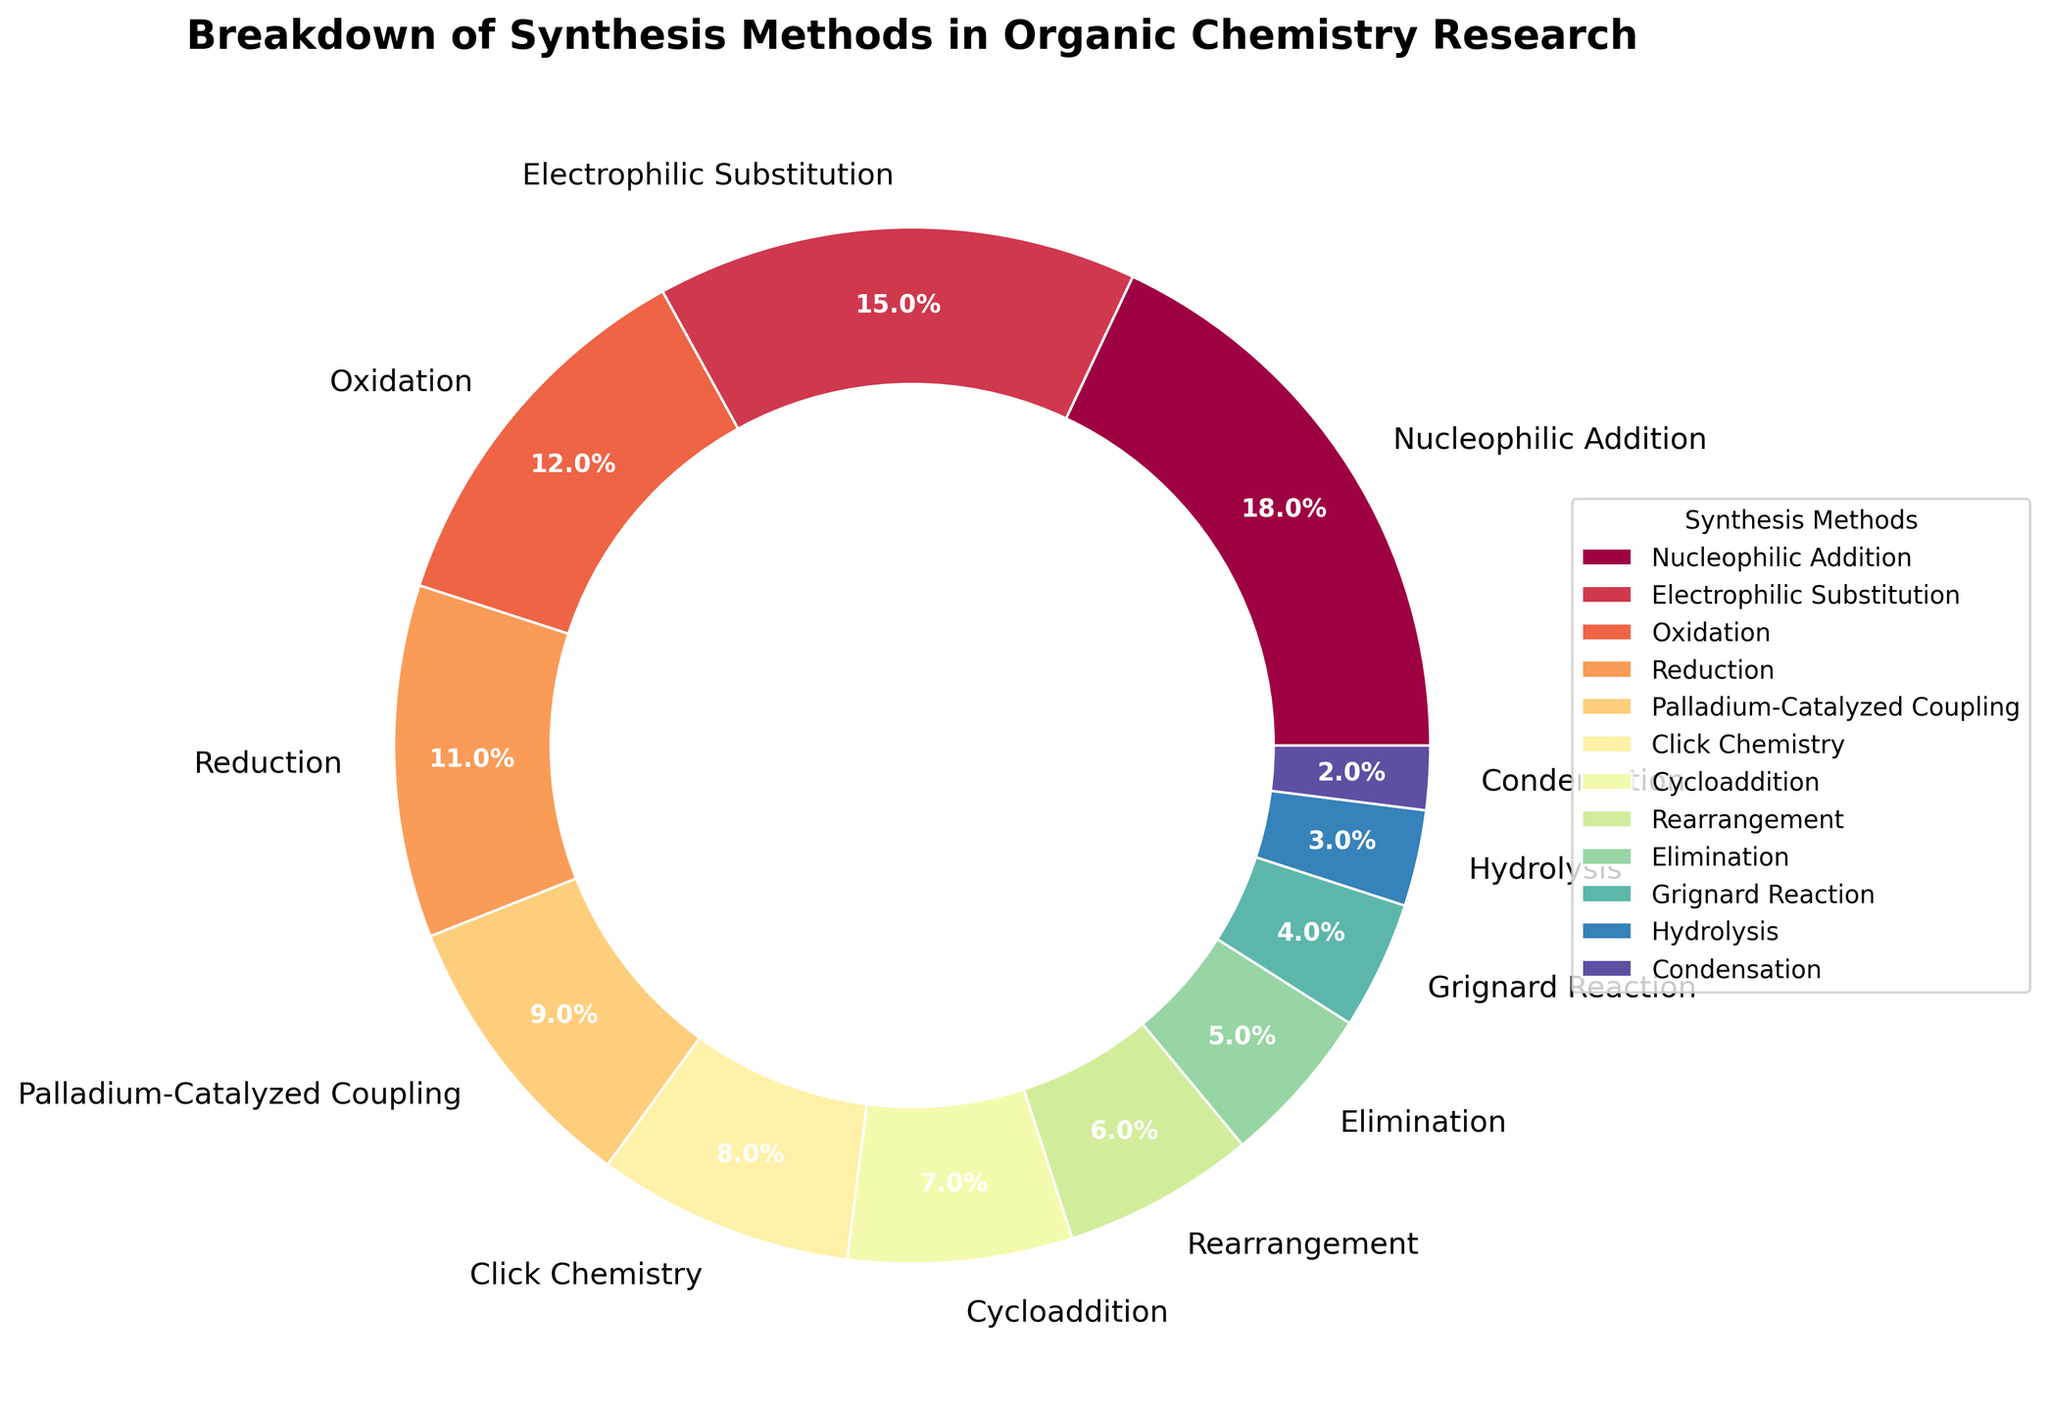Which synthesis method has the highest percentage share in the pie chart? The synthesis method with the highest percentage share can be identified by the largest wedge in the pie chart. The largest wedge corresponds to Nucleophilic Addition.
Answer: Nucleophilic Addition How much higher is the percentage of Nucleophilic Addition compared to Grignard Reaction? To determine how much higher the percentage of Nucleophilic Addition is compared to Grignard Reaction, subtract the percentage of Grignard Reaction (4%) from Nucleophilic Addition (18%). 18% - 4% = 14%.
Answer: 14% What is the combined percentage of Cycloaddition and Click Chemistry? To find the combined percentage of Cycloaddition and Click Chemistry, sum their individual percentages: Cycloaddition (7%) and Click Chemistry (8%). 7% + 8% = 15%.
Answer: 15% Which synthesis method occupies the smallest portion of the pie chart and what is its percentage? The smallest portion of the pie chart corresponds to the wedge that takes up the least space. The wedge for Condensation is the smallest with a percentage of 2%.
Answer: Condensation, 2% Is the percentage of Oxidation greater than the combined percentage of Elimination and Grignard Reaction? First, find the combined percentage of Elimination (5%) and Grignard Reaction (4%), which is 5% + 4% = 9%. The percentage of Oxidation is 12%. Since 12% > 9%, the percentage of Oxidation is indeed greater.
Answer: Yes Arrange the following synthesis methods in decreasing order of their percentage: Reduction, Elimination, Hydrolysis. To arrange these synthesis methods in decreasing order, list their percentages and sort: Reduction (11%), Elimination (5%), Hydrolysis (3%). The order is Reduction > Elimination > Hydrolysis.
Answer: Reduction > Elimination > Hydrolysis What is the difference in percentage between the Palladium-Catalyzed Coupling and Electrophilic Substitution methods? Subtract the percentage of Palladium-Catalyzed Coupling (9%) from the Electrophilic Substitution (15%): 15% - 9% = 6%.
Answer: 6% Does the percentage of Condensation exceed that of Hydrolysis and Grignard Reaction combined? First, sum the percentages of Hydrolysis (3%) and Grignard Reaction (4%). The combined percentage is 3% + 4% = 7%. Compare this with Condensation's 2%. Since 2% is less than 7%, Condensation does not exceed their combined percentage.
Answer: No 